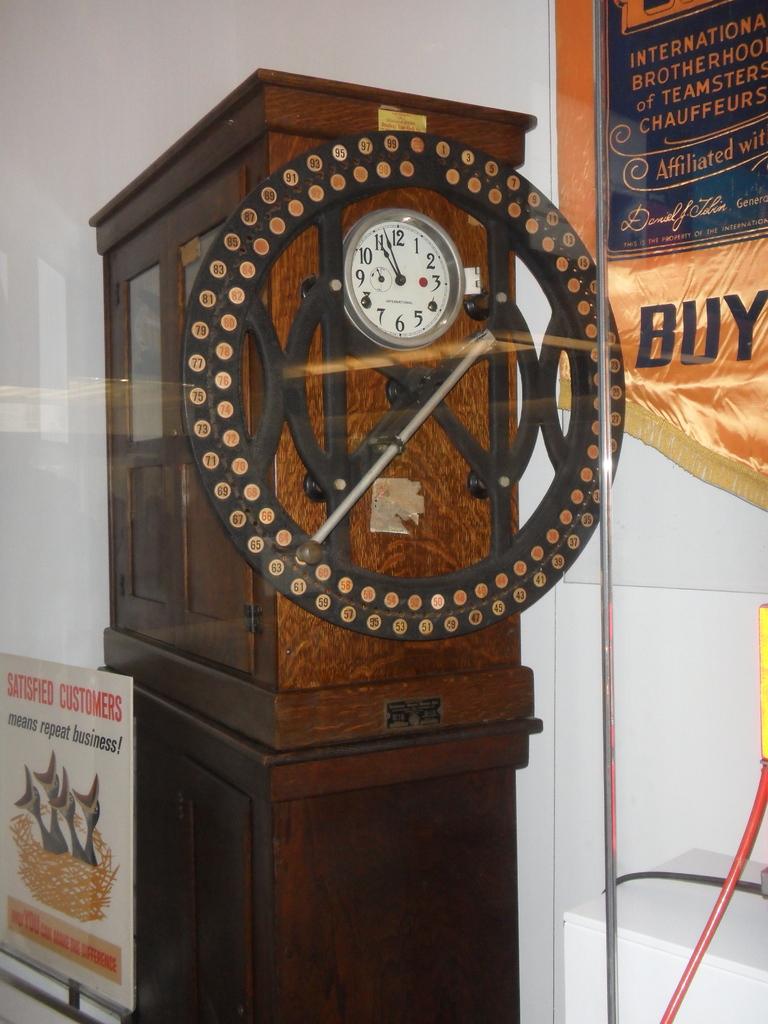What is written on the display on the right side?
Ensure brevity in your answer.  Buy. 